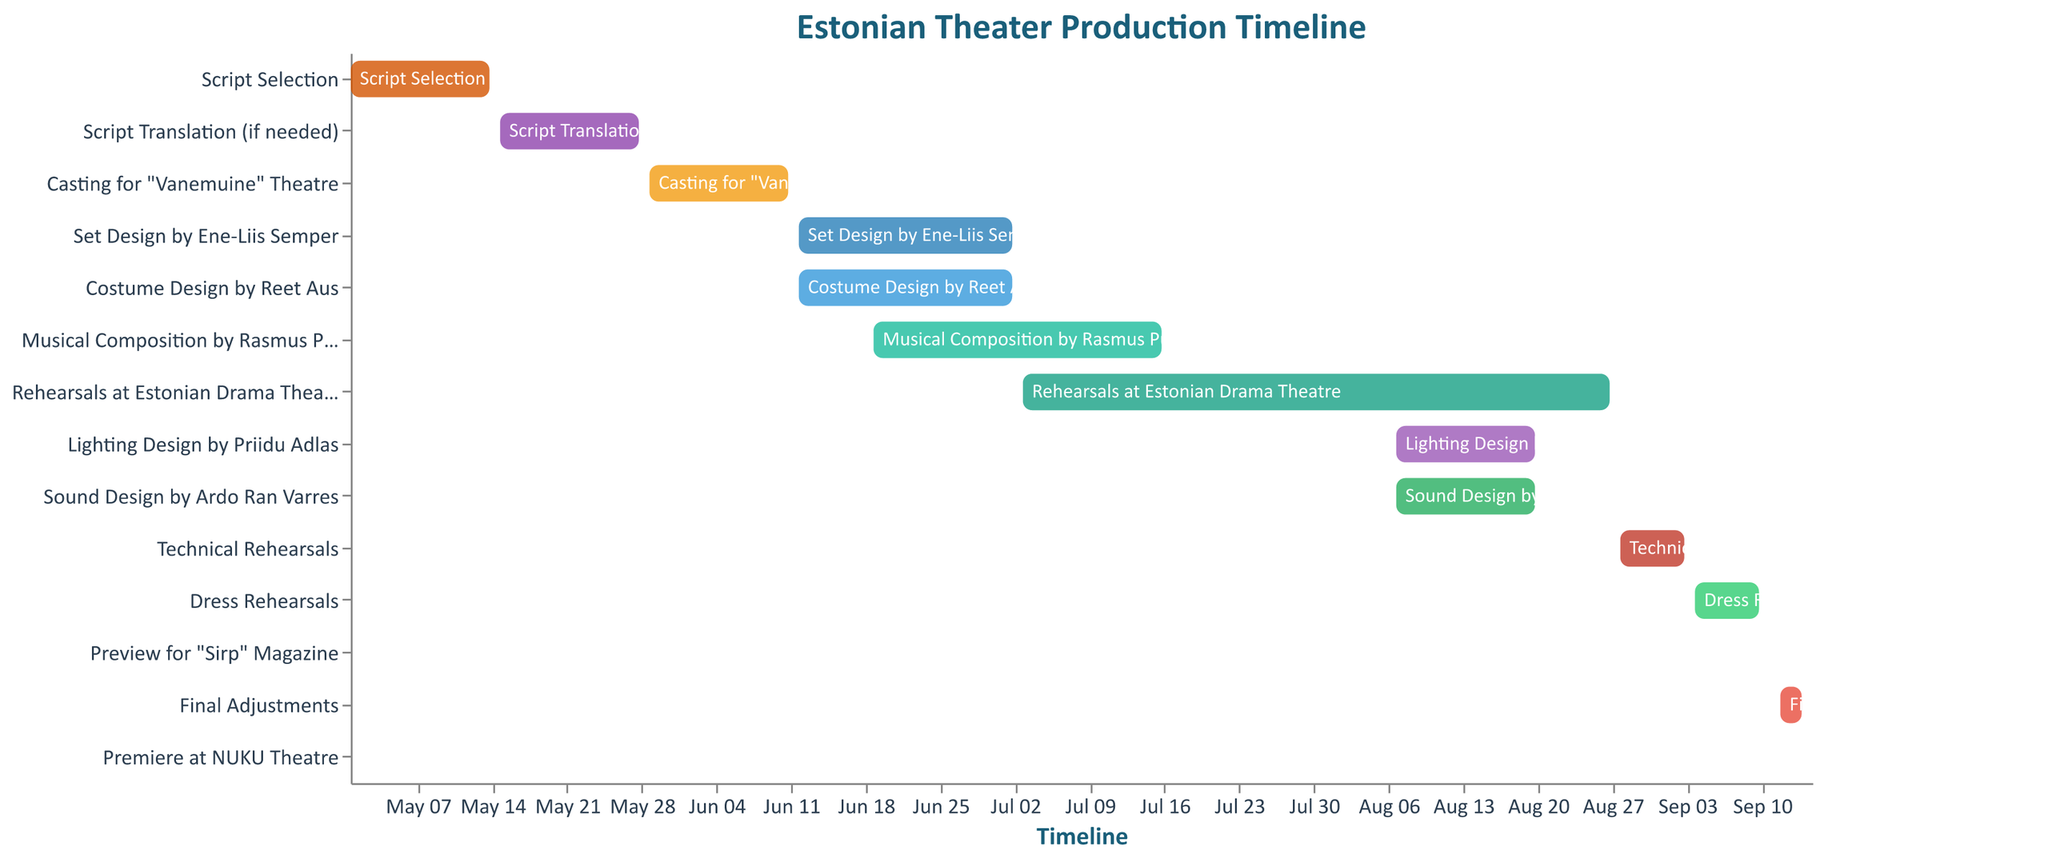How long does the "Set Design by Ene-Liis Semper" stage last? To find the duration of the "Set Design by Ene-Liis Semper", check the start and end dates. It starts on 2023-06-12 and ends on 2023-07-02. The number of days between these dates is 21 days.
Answer: 21 days Which task starts first in the production timeline? Refer to the Gantt chart to identify the earliest start date. The task "Script Selection" starts first on 2023-05-01.
Answer: Script Selection Which two tasks overlap in the timeline? Identify tasks that have overlapping dates visually. "Set Design by Ene-Liis Semper" and "Costume Design by Reet Aus" both start on 2023-06-12 and end on 2023-07-02, indicating an overlap.
Answer: Set Design by Ene-Liis Semper and Costume Design by Reet Aus How much time is allocated to technical rehearsals? Look at the "Technical Rehearsals" start and end dates, which are 2023-08-28 and 2023-09-03, respectively. The duration is 7 days.
Answer: 7 days When does the "Preview for 'Sirp' Magazine" occur in the timeline? Locate the task "Preview for 'Sirp' Magazine" in the Gantt chart. It occurs on 2023-09-11.
Answer: September 11, 2023 What tasks are in progress during July 2023? For each task, check if its timeline includes any days in July 2023. The tasks "Set Design by Ene-Liis Semper" (until 2023-07-02), "Costume Design by Reet Aus" (until 2023-07-02), "Musical Composition by Rasmus Puur" (starts 2023-06-19 to 2023-07-16), and "Rehearsals at Estonian Drama Theatre" (starts 2023-07-03 to 2023-08-27) are in progress during July 2023.
Answer: Set Design by Ene-Liis Semper, Costume Design by Reet Aus, Musical Composition by Rasmus Puur, Rehearsals at Estonian Drama Theatre What is the total duration from the start of "Script Selection" to the "Premiere at NUKU Theatre"? Calculate the duration from 2023-05-01 to 2023-09-15. The total duration is 138 days.
Answer: 138 days Which tasks are assigned to individual designers? Identify tasks that mention specific designers. These are "Set Design by Ene-Liis Semper," "Costume Design by Reet Aus," "Lighting Design by Priidu Adlas," and "Sound Design by Ardo Ran Varres."
Answer: Set Design by Ene-Liis Semper, Costume Design by Reet Aus, Lighting Design by Priidu Adlas, Sound Design by Ardo Ran Varres Do any tasks begin and end on the same date? Find tasks where the start date equals the end date. "Preview for 'Sirp' Magazine" and "Premiere at NUKU Theatre" both occur on a single day.
Answer: Preview for 'Sirp' Magazine, Premiere at NUKU Theatre When do the dress rehearsals take place in the timeline? The "Dress Rehearsals" task runs from 2023-09-04 to 2023-09-10.
Answer: September 4 - 10, 2023 